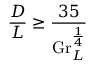<formula> <loc_0><loc_0><loc_500><loc_500>{ \frac { D } { L } } \geq { \frac { 3 5 } { G r _ { L } ^ { \frac { 1 } { 4 } } } }</formula> 